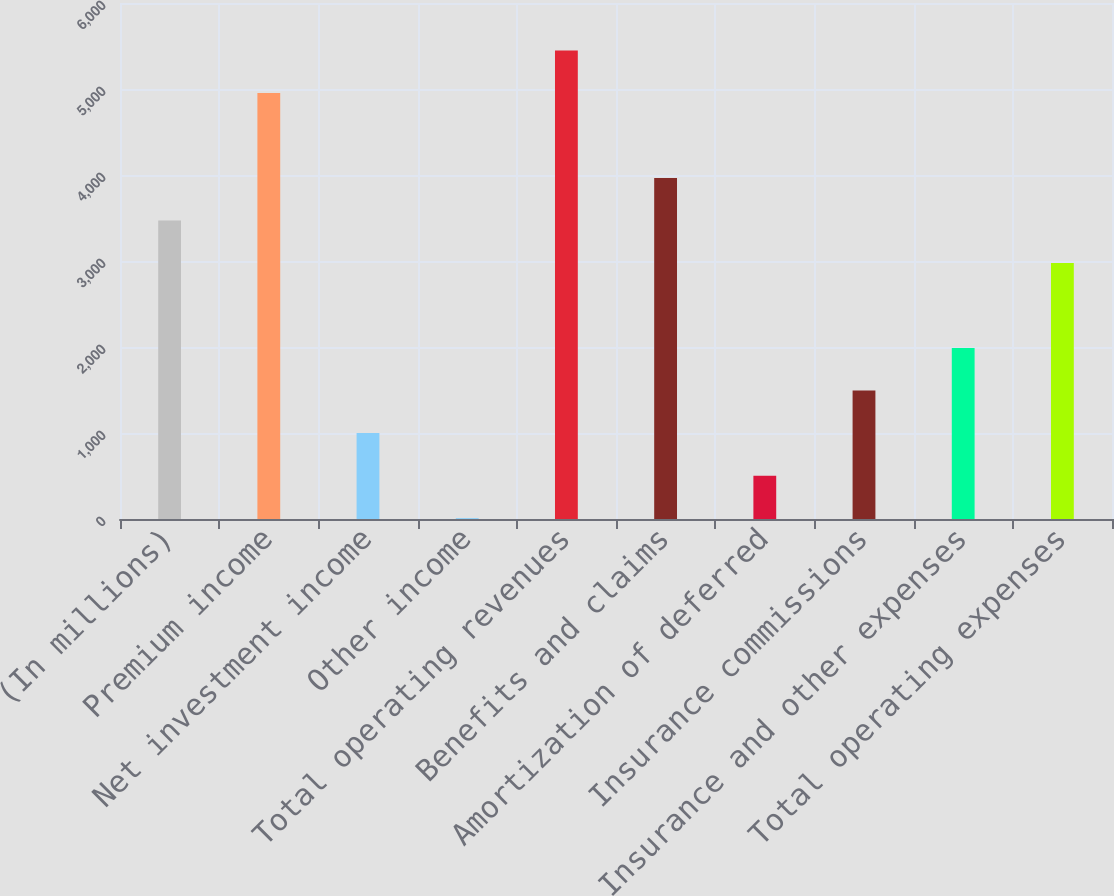<chart> <loc_0><loc_0><loc_500><loc_500><bar_chart><fcel>(In millions)<fcel>Premium income<fcel>Net investment income<fcel>Other income<fcel>Total operating revenues<fcel>Benefits and claims<fcel>Amortization of deferred<fcel>Insurance commissions<fcel>Insurance and other expenses<fcel>Total operating expenses<nl><fcel>3470.1<fcel>4953<fcel>998.6<fcel>10<fcel>5447.3<fcel>3964.4<fcel>504.3<fcel>1492.9<fcel>1987.2<fcel>2975.8<nl></chart> 